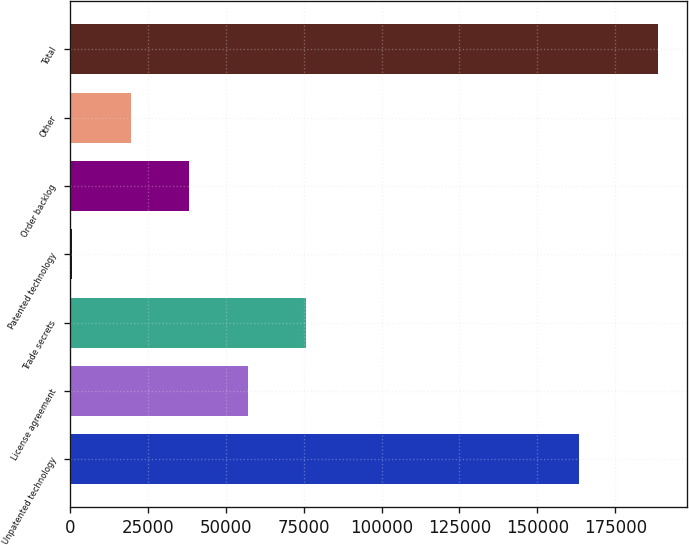<chart> <loc_0><loc_0><loc_500><loc_500><bar_chart><fcel>Unpatented technology<fcel>License agreement<fcel>Trade secrets<fcel>Patented technology<fcel>Order backlog<fcel>Other<fcel>Total<nl><fcel>163313<fcel>57094<fcel>75876<fcel>748<fcel>38312<fcel>19530<fcel>188568<nl></chart> 